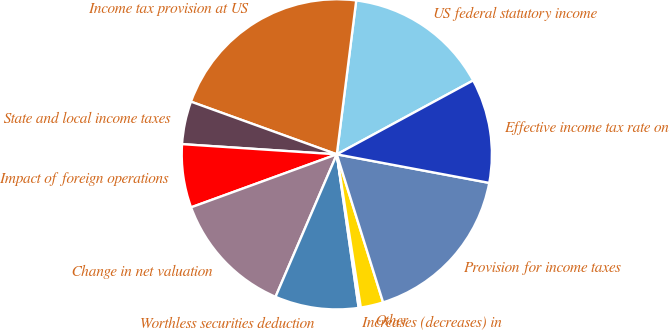Convert chart to OTSL. <chart><loc_0><loc_0><loc_500><loc_500><pie_chart><fcel>US federal statutory income<fcel>Income tax provision at US<fcel>State and local income taxes<fcel>Impact of foreign operations<fcel>Change in net valuation<fcel>Worthless securities deduction<fcel>Increases (decreases) in<fcel>Other<fcel>Provision for income taxes<fcel>Effective income tax rate on<nl><fcel>15.1%<fcel>21.48%<fcel>4.47%<fcel>6.6%<fcel>12.98%<fcel>8.72%<fcel>0.22%<fcel>2.35%<fcel>17.23%<fcel>10.85%<nl></chart> 